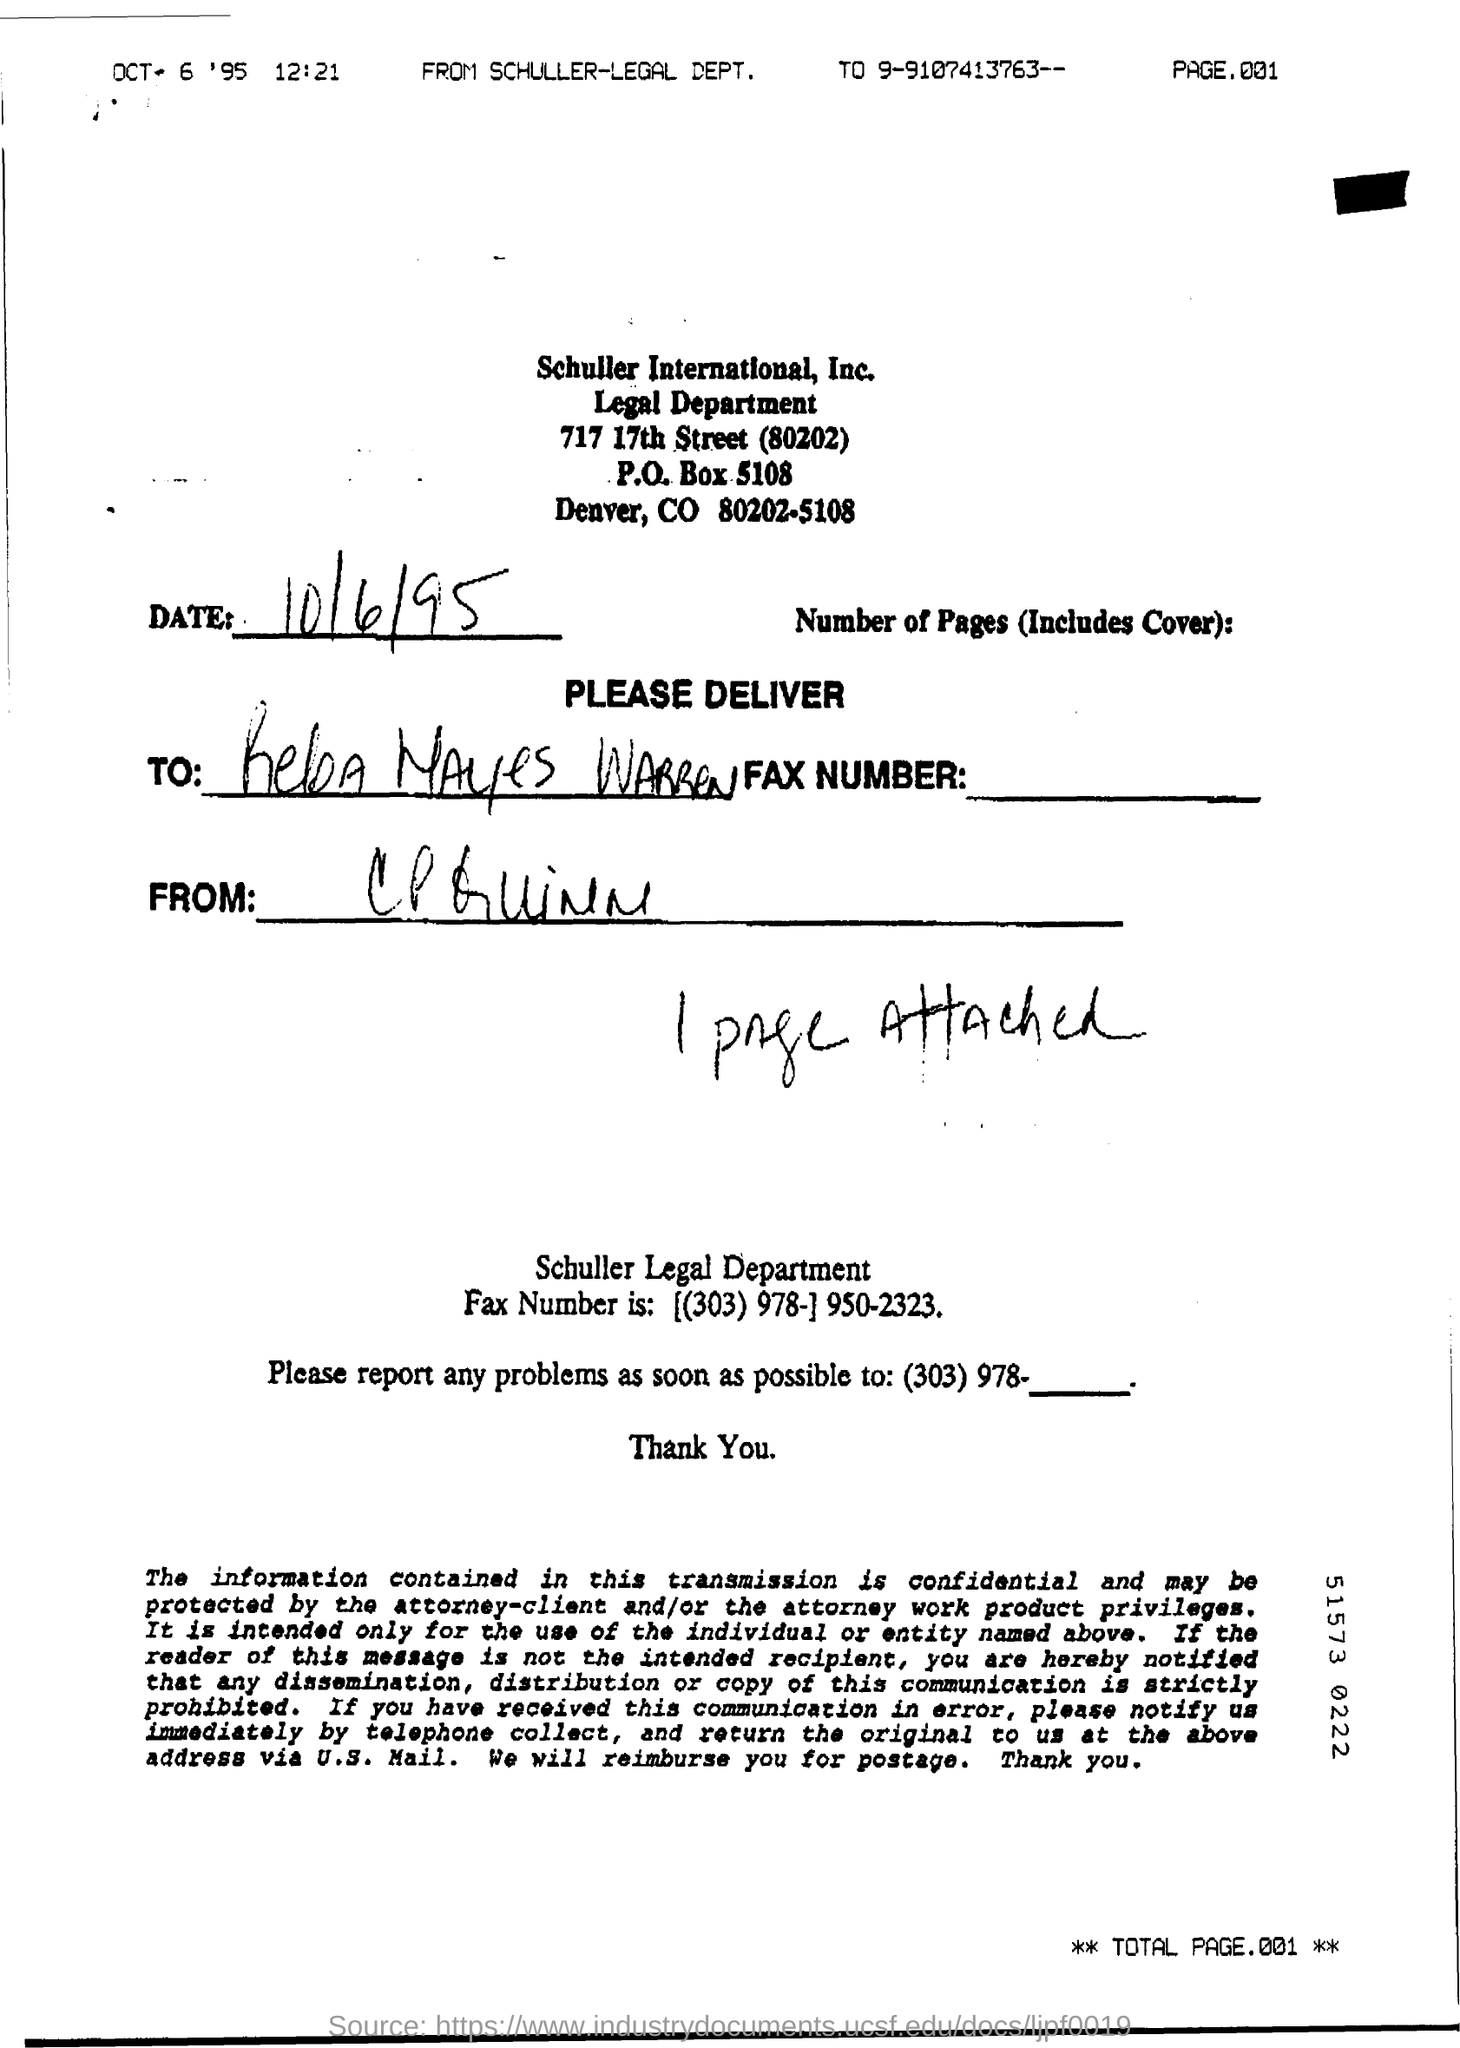What is the Page No: of the document?
Your response must be concise. 001. What is the date of the document?
Your answer should be very brief. OCT 6 '95. What is the time mentioned ?
Ensure brevity in your answer.  12.21. Which is the department of Schuller International Inc. Company printed this document?
Provide a short and direct response. Legal Department. How many pages are attached along with the document?
Offer a very short reply. 1. 